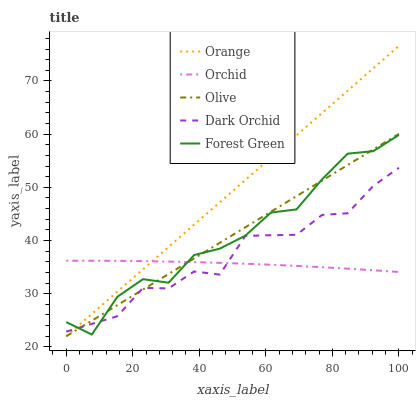Does Orchid have the minimum area under the curve?
Answer yes or no. Yes. Does Orange have the maximum area under the curve?
Answer yes or no. Yes. Does Olive have the minimum area under the curve?
Answer yes or no. No. Does Olive have the maximum area under the curve?
Answer yes or no. No. Is Orange the smoothest?
Answer yes or no. Yes. Is Forest Green the roughest?
Answer yes or no. Yes. Is Olive the smoothest?
Answer yes or no. No. Is Olive the roughest?
Answer yes or no. No. Does Forest Green have the lowest value?
Answer yes or no. No. Does Orange have the highest value?
Answer yes or no. Yes. Does Olive have the highest value?
Answer yes or no. No. Does Orchid intersect Orange?
Answer yes or no. Yes. Is Orchid less than Orange?
Answer yes or no. No. Is Orchid greater than Orange?
Answer yes or no. No. 